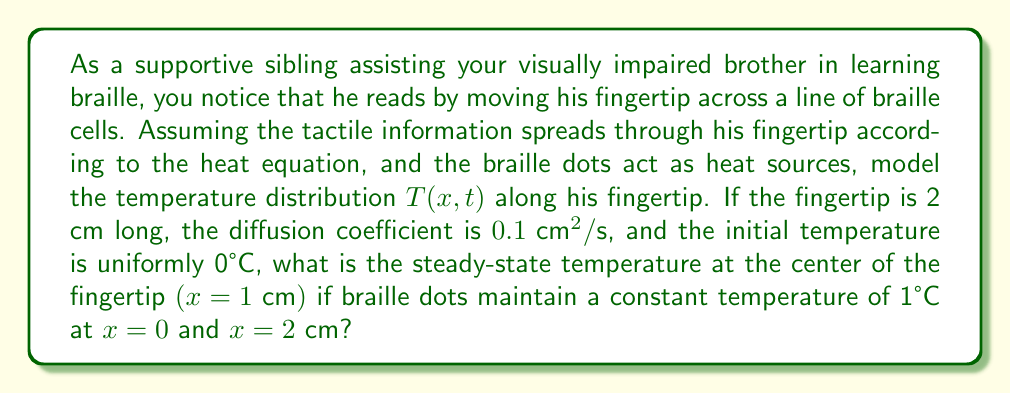Help me with this question. Let's approach this step-by-step:

1) The heat equation in one dimension is:

   $$\frac{\partial T}{\partial t} = D \frac{\partial^2 T}{\partial x^2}$$

   where $D$ is the diffusion coefficient.

2) For the steady-state solution, $\frac{\partial T}{\partial t} = 0$, so we have:

   $$0 = D \frac{d^2 T}{dx^2}$$

3) Integrating twice:

   $$T(x) = Ax + B$$

   where $A$ and $B$ are constants to be determined from the boundary conditions.

4) The boundary conditions are:

   $T(0) = 1$ and $T(2) = 1$

5) Applying these conditions:

   $T(0) = B = 1$
   $T(2) = 2A + 1 = 1$

6) From the second equation:

   $2A = 0$
   $A = 0$

7) Therefore, the steady-state solution is:

   $$T(x) = 1$$

8) This means the temperature is uniformly 1°C along the entire fingertip in the steady state, regardless of the diffusion coefficient.

9) At the center of the fingertip $(x = 1 \text{ cm})$, the temperature is also 1°C.
Answer: 1°C 